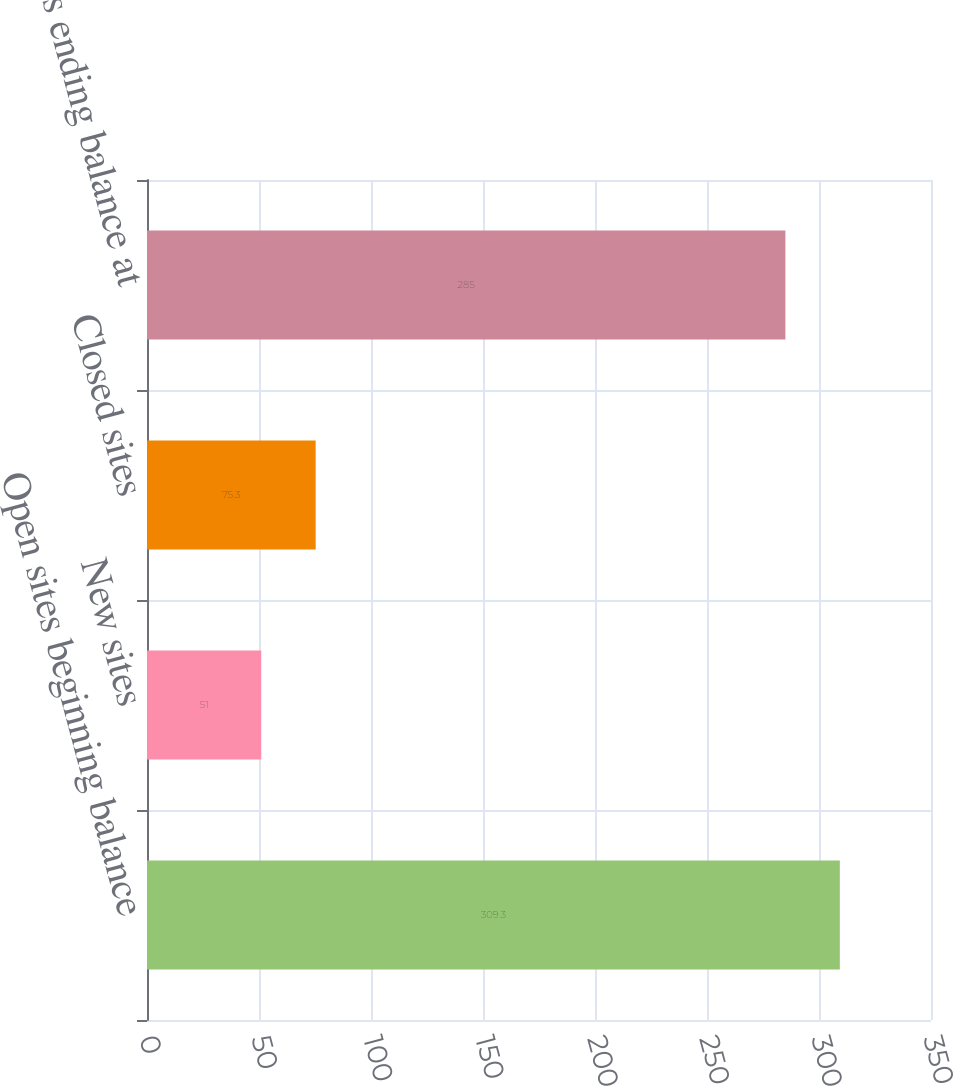Convert chart to OTSL. <chart><loc_0><loc_0><loc_500><loc_500><bar_chart><fcel>Open sites beginning balance<fcel>New sites<fcel>Closed sites<fcel>Open sites ending balance at<nl><fcel>309.3<fcel>51<fcel>75.3<fcel>285<nl></chart> 